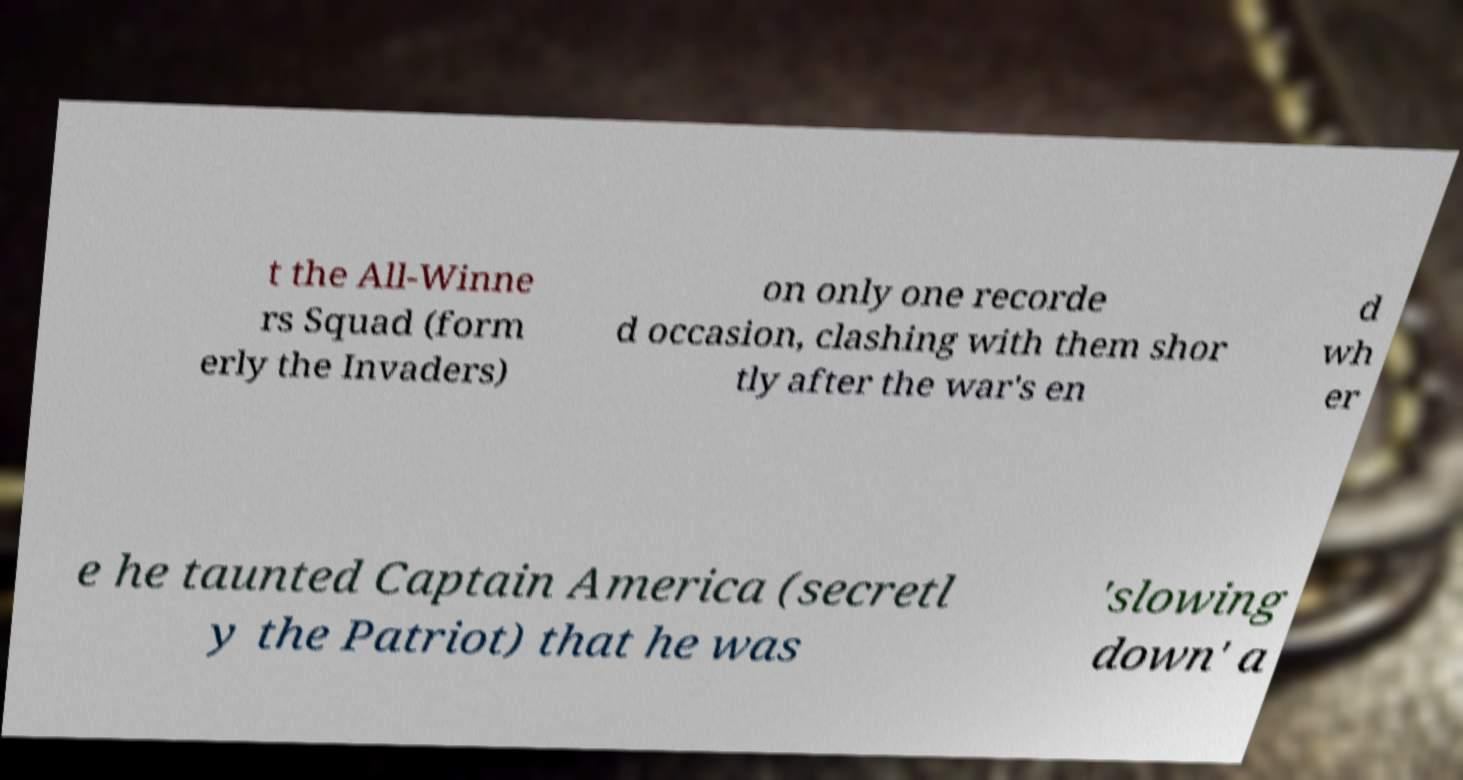There's text embedded in this image that I need extracted. Can you transcribe it verbatim? t the All-Winne rs Squad (form erly the Invaders) on only one recorde d occasion, clashing with them shor tly after the war's en d wh er e he taunted Captain America (secretl y the Patriot) that he was 'slowing down' a 